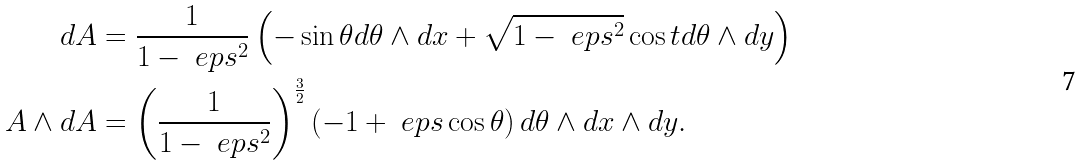Convert formula to latex. <formula><loc_0><loc_0><loc_500><loc_500>d A & = \frac { 1 } { 1 - \ e p s ^ { 2 } } \left ( - \sin \theta d \theta \wedge d x + \sqrt { 1 - \ e p s ^ { 2 } } \cos t d \theta \wedge d y \right ) \\ A \wedge d A & = \left ( \frac { 1 } { 1 - \ e p s ^ { 2 } } \right ) ^ { \frac { 3 } { 2 } } \left ( - 1 + \ e p s \cos \theta \right ) d \theta \wedge d x \wedge d y .</formula> 